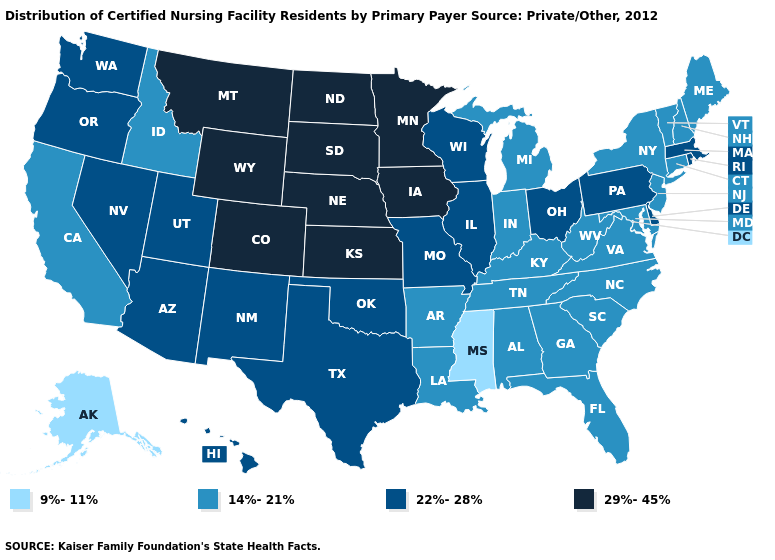Name the states that have a value in the range 14%-21%?
Write a very short answer. Alabama, Arkansas, California, Connecticut, Florida, Georgia, Idaho, Indiana, Kentucky, Louisiana, Maine, Maryland, Michigan, New Hampshire, New Jersey, New York, North Carolina, South Carolina, Tennessee, Vermont, Virginia, West Virginia. What is the highest value in the USA?
Give a very brief answer. 29%-45%. What is the lowest value in the USA?
Keep it brief. 9%-11%. Does Rhode Island have a lower value than Tennessee?
Short answer required. No. What is the highest value in the USA?
Concise answer only. 29%-45%. Among the states that border Massachusetts , does New York have the lowest value?
Give a very brief answer. Yes. Does New Hampshire have the highest value in the Northeast?
Quick response, please. No. What is the value of South Dakota?
Answer briefly. 29%-45%. What is the value of West Virginia?
Short answer required. 14%-21%. What is the highest value in the USA?
Short answer required. 29%-45%. What is the lowest value in states that border Nevada?
Short answer required. 14%-21%. What is the value of Arizona?
Keep it brief. 22%-28%. Does Connecticut have a higher value than South Carolina?
Keep it brief. No. 